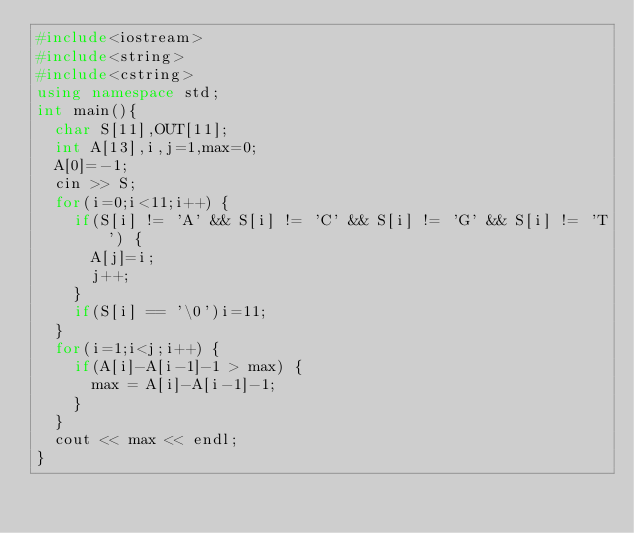Convert code to text. <code><loc_0><loc_0><loc_500><loc_500><_C++_>#include<iostream>
#include<string>
#include<cstring>
using namespace std;
int main(){
  char S[11],OUT[11];
  int A[13],i,j=1,max=0;
  A[0]=-1;
  cin >> S;
  for(i=0;i<11;i++) {
    if(S[i] != 'A' && S[i] != 'C' && S[i] != 'G' && S[i] != 'T') {
      A[j]=i;
      j++;
    }
    if(S[i] == '\0')i=11;
  }
  for(i=1;i<j;i++) {
    if(A[i]-A[i-1]-1 > max) {
      max = A[i]-A[i-1]-1;
    }
  }
  cout << max << endl;
}</code> 